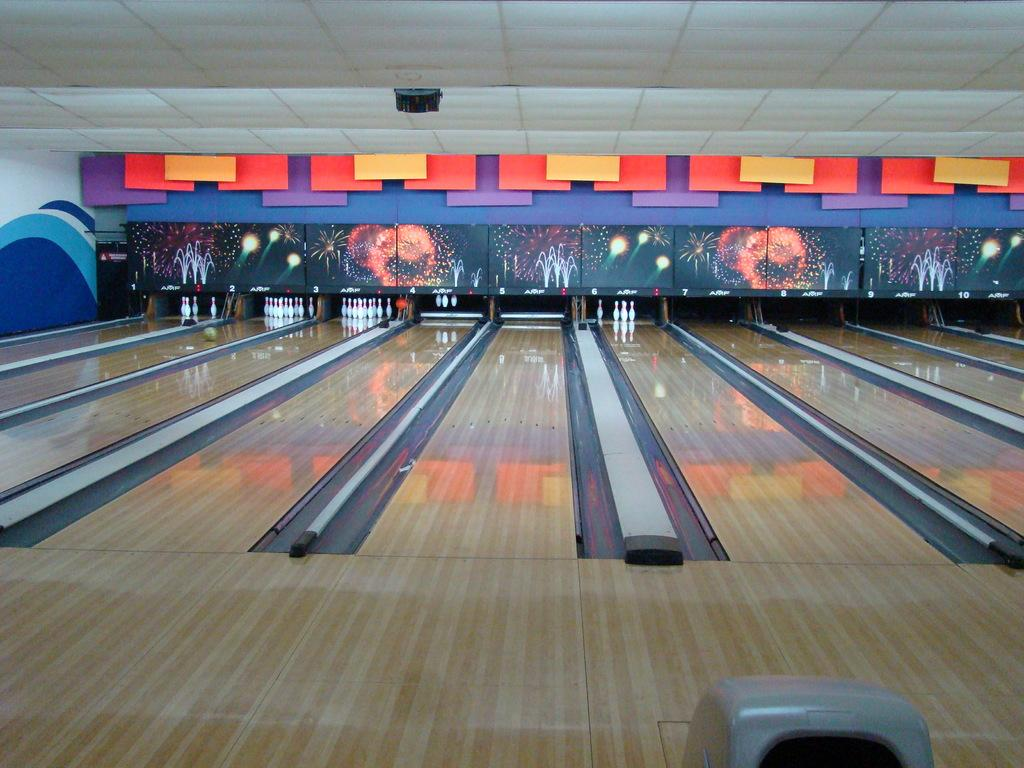What color are the objects in the image? The objects in the image are white. What activity are the objects used for? The objects are used for bowling. Are there any frogs visible in the image? No, there are no frogs present in the image. What type of profit can be made from the objects in the image? The image does not provide information about making a profit from the objects, as it only shows them being used for bowling. 